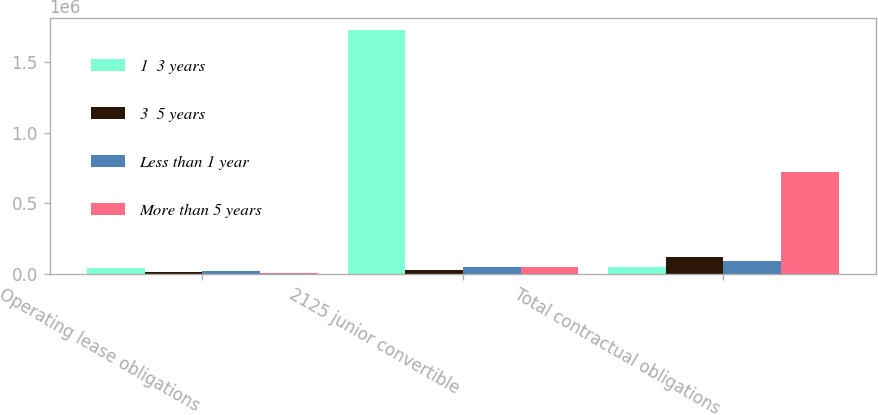Convert chart. <chart><loc_0><loc_0><loc_500><loc_500><stacked_bar_chart><ecel><fcel>Operating lease obligations<fcel>2125 junior convertible<fcel>Total contractual obligations<nl><fcel>1  3 years<fcel>42264<fcel>1.72937e+06<fcel>48875<nl><fcel>3  5 years<fcel>12415<fcel>24438<fcel>123003<nl><fcel>Less than 1 year<fcel>20048<fcel>48875<fcel>90490<nl><fcel>More than 5 years<fcel>9402<fcel>48875<fcel>721714<nl></chart> 